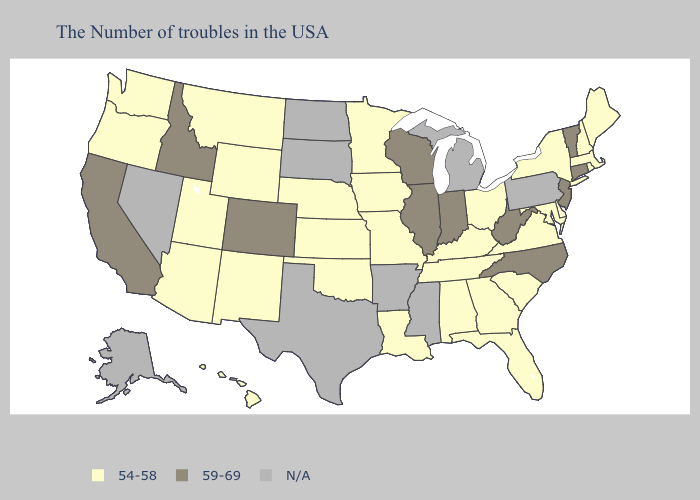Does Connecticut have the lowest value in the Northeast?
Give a very brief answer. No. Name the states that have a value in the range N/A?
Answer briefly. Pennsylvania, Michigan, Mississippi, Arkansas, Texas, South Dakota, North Dakota, Nevada, Alaska. What is the value of Montana?
Answer briefly. 54-58. Among the states that border Maryland , does West Virginia have the lowest value?
Concise answer only. No. What is the value of North Carolina?
Concise answer only. 59-69. Name the states that have a value in the range 54-58?
Concise answer only. Maine, Massachusetts, Rhode Island, New Hampshire, New York, Delaware, Maryland, Virginia, South Carolina, Ohio, Florida, Georgia, Kentucky, Alabama, Tennessee, Louisiana, Missouri, Minnesota, Iowa, Kansas, Nebraska, Oklahoma, Wyoming, New Mexico, Utah, Montana, Arizona, Washington, Oregon, Hawaii. Which states have the highest value in the USA?
Write a very short answer. Vermont, Connecticut, New Jersey, North Carolina, West Virginia, Indiana, Wisconsin, Illinois, Colorado, Idaho, California. Among the states that border Tennessee , which have the highest value?
Write a very short answer. North Carolina. Name the states that have a value in the range 54-58?
Give a very brief answer. Maine, Massachusetts, Rhode Island, New Hampshire, New York, Delaware, Maryland, Virginia, South Carolina, Ohio, Florida, Georgia, Kentucky, Alabama, Tennessee, Louisiana, Missouri, Minnesota, Iowa, Kansas, Nebraska, Oklahoma, Wyoming, New Mexico, Utah, Montana, Arizona, Washington, Oregon, Hawaii. Does Minnesota have the lowest value in the USA?
Be succinct. Yes. Name the states that have a value in the range N/A?
Be succinct. Pennsylvania, Michigan, Mississippi, Arkansas, Texas, South Dakota, North Dakota, Nevada, Alaska. Name the states that have a value in the range 54-58?
Short answer required. Maine, Massachusetts, Rhode Island, New Hampshire, New York, Delaware, Maryland, Virginia, South Carolina, Ohio, Florida, Georgia, Kentucky, Alabama, Tennessee, Louisiana, Missouri, Minnesota, Iowa, Kansas, Nebraska, Oklahoma, Wyoming, New Mexico, Utah, Montana, Arizona, Washington, Oregon, Hawaii. Does the first symbol in the legend represent the smallest category?
Quick response, please. Yes. What is the value of Idaho?
Keep it brief. 59-69. 